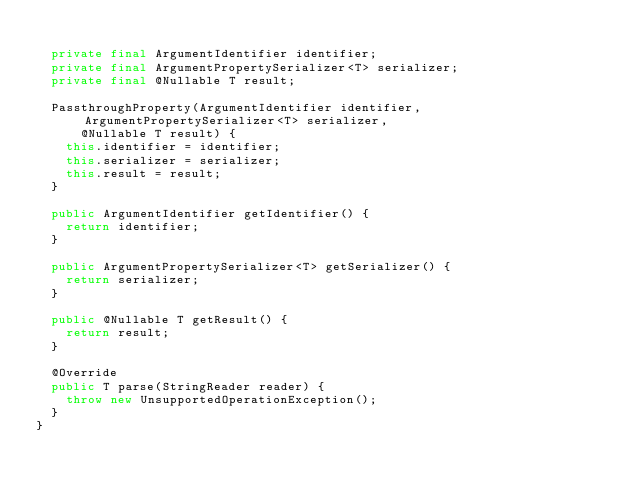<code> <loc_0><loc_0><loc_500><loc_500><_Java_>
  private final ArgumentIdentifier identifier;
  private final ArgumentPropertySerializer<T> serializer;
  private final @Nullable T result;

  PassthroughProperty(ArgumentIdentifier identifier, ArgumentPropertySerializer<T> serializer,
      @Nullable T result) {
    this.identifier = identifier;
    this.serializer = serializer;
    this.result = result;
  }

  public ArgumentIdentifier getIdentifier() {
    return identifier;
  }

  public ArgumentPropertySerializer<T> getSerializer() {
    return serializer;
  }

  public @Nullable T getResult() {
    return result;
  }

  @Override
  public T parse(StringReader reader) {
    throw new UnsupportedOperationException();
  }
}
</code> 